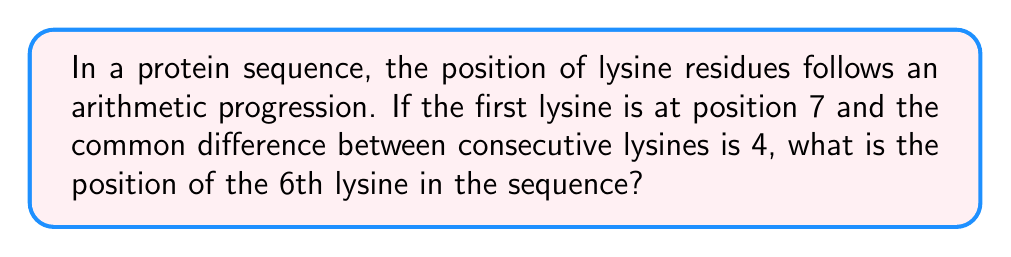Give your solution to this math problem. Let's approach this step-by-step using the arithmetic progression formula:

1) The general term of an arithmetic progression is given by:
   $$a_n = a_1 + (n-1)d$$
   Where:
   $a_n$ is the nth term
   $a_1$ is the first term
   $n$ is the position of the term
   $d$ is the common difference

2) In this case:
   $a_1 = 7$ (position of the first lysine)
   $d = 4$ (common difference)
   $n = 6$ (we're looking for the 6th lysine)

3) Substituting these values into the formula:
   $$a_6 = 7 + (6-1)4$$

4) Simplify:
   $$a_6 = 7 + (5)4$$
   $$a_6 = 7 + 20$$
   $$a_6 = 27$$

Therefore, the 6th lysine in the sequence is at position 27.
Answer: 27 